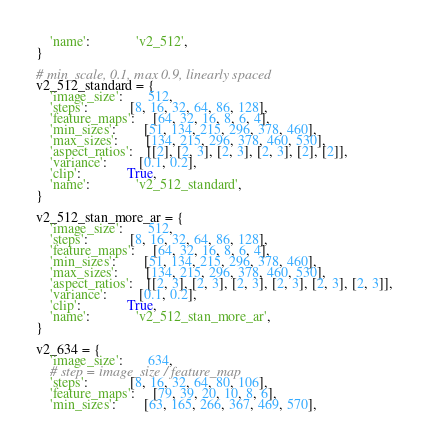<code> <loc_0><loc_0><loc_500><loc_500><_Python_>    'name':             'v2_512',
}

# min_scale, 0.1, max 0.9, linearly spaced
v2_512_standard = {
    'image_size':       512,
    'steps':            [8, 16, 32, 64, 86, 128],
    'feature_maps':     [64, 32, 16, 8, 6, 4],
    'min_sizes':        [51, 134, 215, 296, 378, 460],
    'max_sizes':        [134, 215, 296, 378, 460, 530],
    'aspect_ratios':    [[2], [2, 3], [2, 3], [2, 3], [2], [2]],
    'variance':         [0.1, 0.2],
    'clip':             True,
    'name':             'v2_512_standard',
}

v2_512_stan_more_ar = {
    'image_size':       512,
    'steps':            [8, 16, 32, 64, 86, 128],
    'feature_maps':     [64, 32, 16, 8, 6, 4],
    'min_sizes':        [51, 134, 215, 296, 378, 460],
    'max_sizes':        [134, 215, 296, 378, 460, 530],
    'aspect_ratios':    [[2, 3], [2, 3], [2, 3], [2, 3], [2, 3], [2, 3]],
    'variance':         [0.1, 0.2],
    'clip':             True,
    'name':             'v2_512_stan_more_ar',
}

v2_634 = {
    'image_size':       634,
    # step = image_size / feature_map
    'steps':            [8, 16, 32, 64, 80, 106],
    'feature_maps':     [79, 39, 20, 10, 8, 6],
    'min_sizes':        [63, 165, 266, 367, 469, 570],</code> 